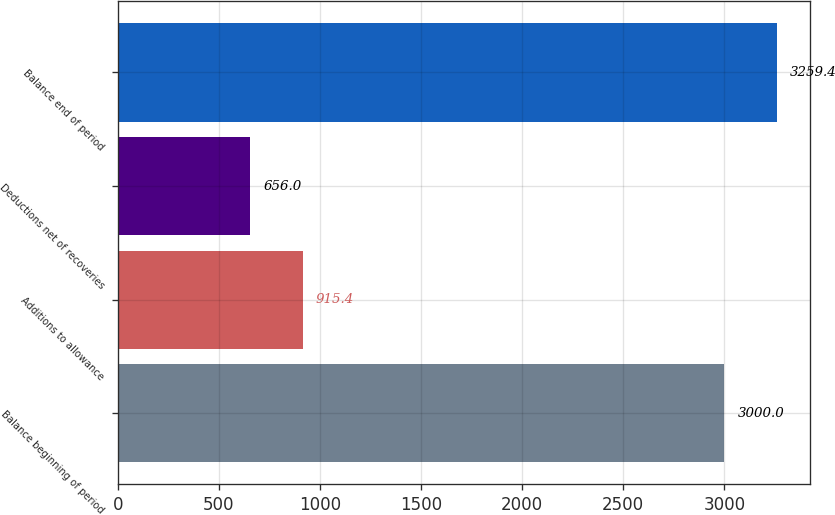<chart> <loc_0><loc_0><loc_500><loc_500><bar_chart><fcel>Balance beginning of period<fcel>Additions to allowance<fcel>Deductions net of recoveries<fcel>Balance end of period<nl><fcel>3000<fcel>915.4<fcel>656<fcel>3259.4<nl></chart> 